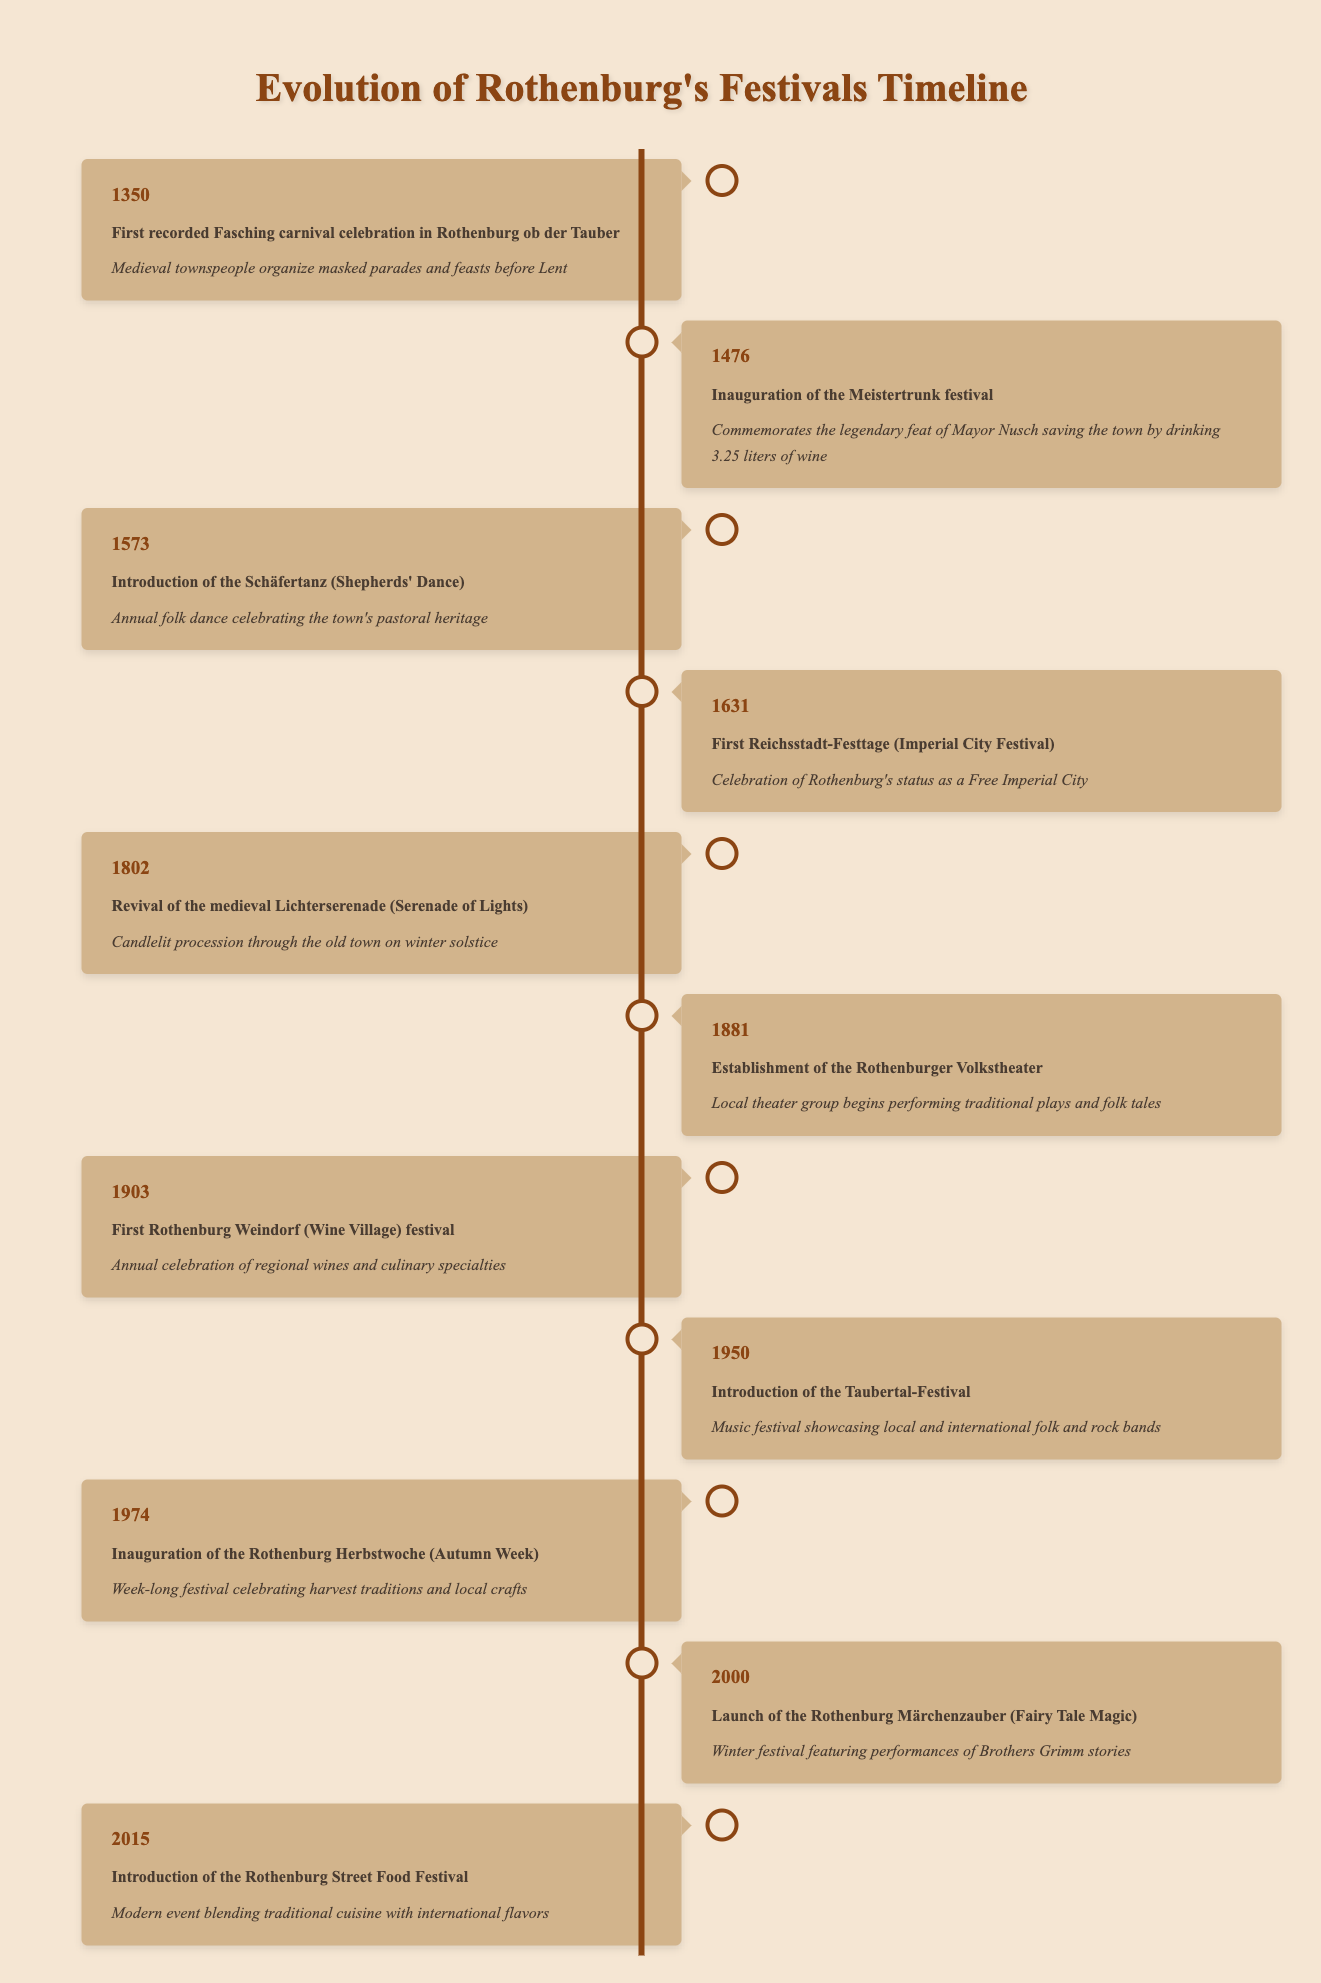What year did the first recorded Fasching carnival celebration occur? The table shows that the first recorded Fasching carnival celebration in Rothenburg ob der Tauber occurred in the year 1350.
Answer: 1350 How many events were introduced before the 20th century? By examining the years listed in the table, we can count the events chronologically: 1350, 1476, 1573, 1631, 1802, and 1881, which totals six events before the year 1900.
Answer: 6 Was the Meistertrunk festival established before or after the introduction of the Schäfertanz? The Meistertrunk festival was inaugurated in 1476 and the Schäfertanz was introduced in 1573. Since 1476 is before 1573, the Meistertrunk festival was established before the Schäfertanz.
Answer: Before Which event features performances based on the Brothers Grimm stories? The Rothenburg Märchenzauber (Fairy Tale Magic) launched in 2000 features performances of Brothers Grimm stories, as noted in the description.
Answer: Rothenburg Märchenzauber What is the time span between the first recorded Fasching celebration and the launch of the Street Food Festival? The first recorded Fasching celebration was in 1350 and the Street Food Festival was introduced in 2015. To find the time span, we subtract 1350 from 2015, giving us 665 years.
Answer: 665 years Is it true that the first Rothenburg Weindorf festival was celebrated in the 19th century? The table shows that the first Rothenburg Weindorf festival occurred in 1903, which is in the 20th century, not the 19th century. Therefore, the statement is false.
Answer: False What three traditional aspects does the Rothenburg Herbstwoche celebrate? The table indicates that the Rothenburg Herbstwoche celebrates harvest traditions and local crafts. Harvest traditions can be considered one of the main traditional aspects, but the exact number of aspects isn't specified in the table. Therefore, the answer is that it celebrates harvest traditions and local crafts.
Answer: Harvest traditions and local crafts How many festival events happened in the 21st century according to the table? The events listed in the table for the 21st century are Rothenburg Märchenzauber established in 2000 and the Rothenburg Street Food Festival in 2015. This totals two events in the 21st century.
Answer: 2 